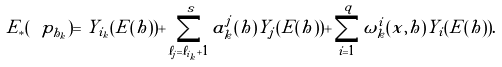Convert formula to latex. <formula><loc_0><loc_0><loc_500><loc_500>E _ { * } ( \ p _ { h _ { k } } ) = Y _ { i _ { k } } ( E ( h ) ) + \sum _ { \ell _ { j } = \ell _ { i _ { k } } + 1 } ^ { s } a ^ { j } _ { k } ( h ) Y _ { j } ( E ( h ) ) + \sum _ { i = 1 } ^ { q } \omega _ { k } ^ { i } ( x , h ) Y _ { i } ( E ( h ) ) .</formula> 